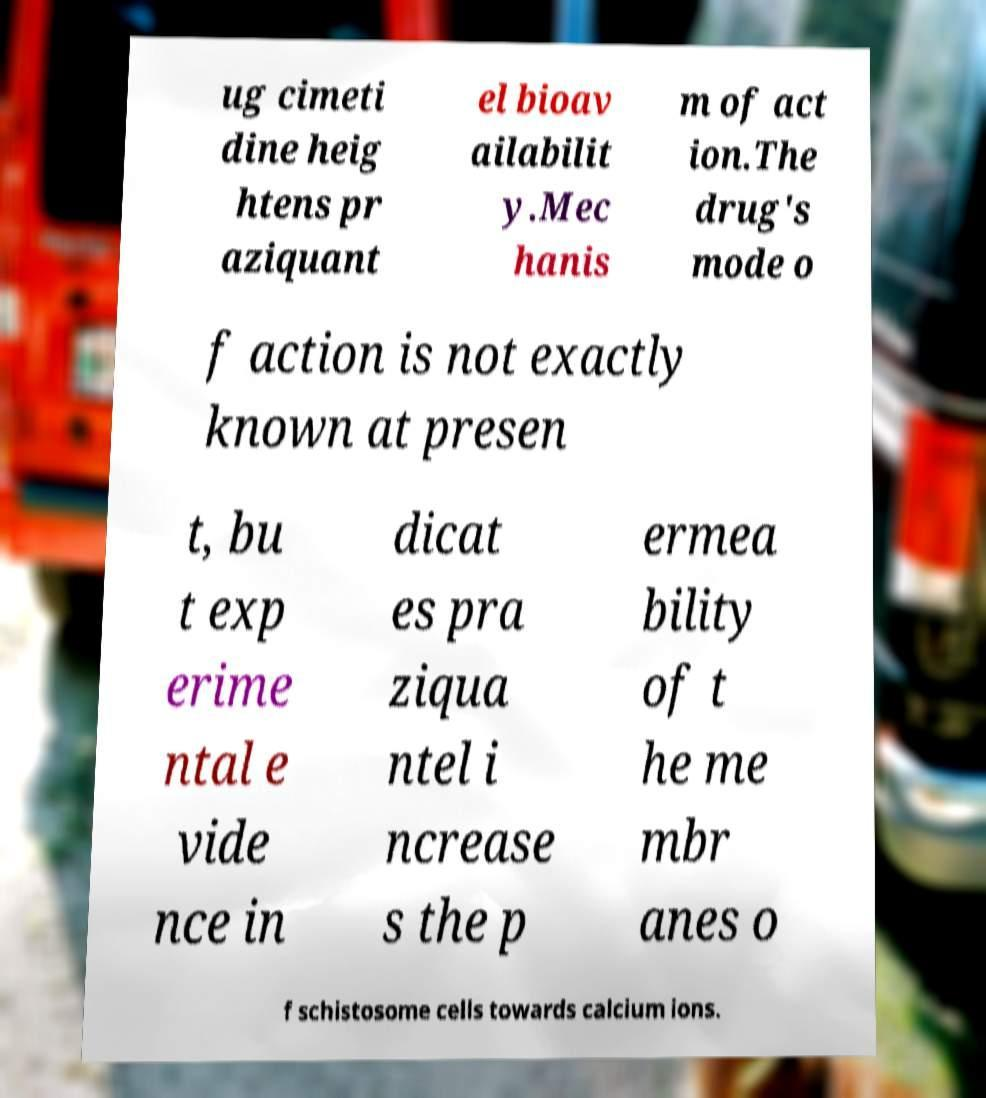Could you extract and type out the text from this image? ug cimeti dine heig htens pr aziquant el bioav ailabilit y.Mec hanis m of act ion.The drug's mode o f action is not exactly known at presen t, bu t exp erime ntal e vide nce in dicat es pra ziqua ntel i ncrease s the p ermea bility of t he me mbr anes o f schistosome cells towards calcium ions. 